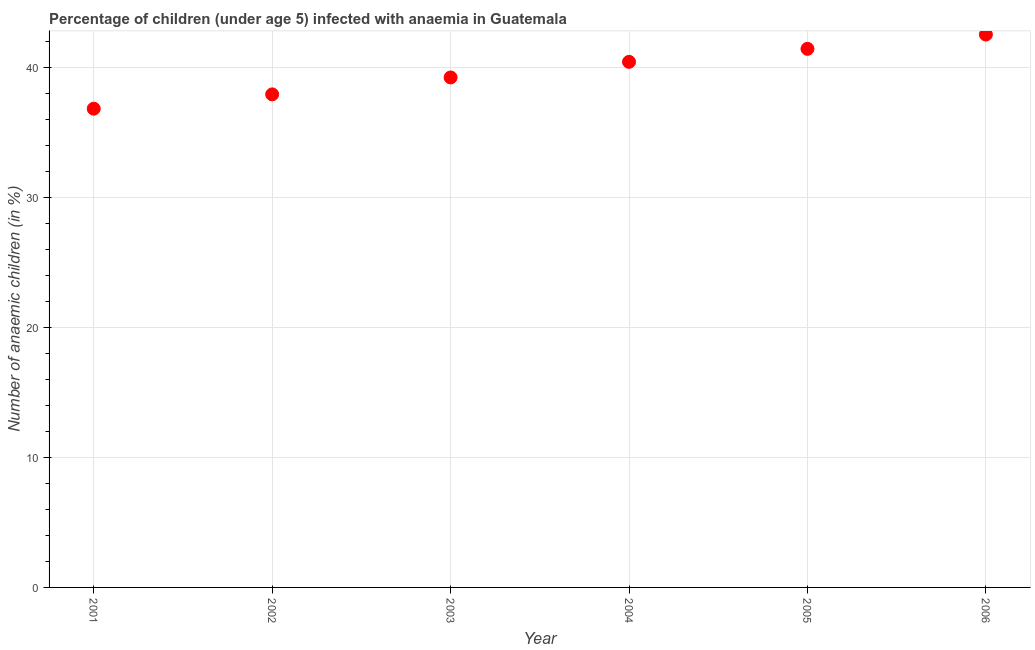What is the number of anaemic children in 2005?
Give a very brief answer. 41.4. Across all years, what is the maximum number of anaemic children?
Your answer should be very brief. 42.5. Across all years, what is the minimum number of anaemic children?
Provide a short and direct response. 36.8. In which year was the number of anaemic children minimum?
Provide a succinct answer. 2001. What is the sum of the number of anaemic children?
Offer a very short reply. 238.2. What is the difference between the number of anaemic children in 2002 and 2006?
Ensure brevity in your answer.  -4.6. What is the average number of anaemic children per year?
Make the answer very short. 39.7. What is the median number of anaemic children?
Your answer should be very brief. 39.8. Do a majority of the years between 2004 and 2002 (inclusive) have number of anaemic children greater than 38 %?
Your answer should be very brief. No. What is the ratio of the number of anaemic children in 2002 to that in 2004?
Give a very brief answer. 0.94. What is the difference between the highest and the second highest number of anaemic children?
Offer a very short reply. 1.1. What is the difference between the highest and the lowest number of anaemic children?
Keep it short and to the point. 5.7. Does the number of anaemic children monotonically increase over the years?
Make the answer very short. Yes. How many years are there in the graph?
Offer a terse response. 6. What is the difference between two consecutive major ticks on the Y-axis?
Ensure brevity in your answer.  10. Does the graph contain any zero values?
Offer a very short reply. No. Does the graph contain grids?
Offer a very short reply. Yes. What is the title of the graph?
Offer a very short reply. Percentage of children (under age 5) infected with anaemia in Guatemala. What is the label or title of the Y-axis?
Keep it short and to the point. Number of anaemic children (in %). What is the Number of anaemic children (in %) in 2001?
Give a very brief answer. 36.8. What is the Number of anaemic children (in %) in 2002?
Make the answer very short. 37.9. What is the Number of anaemic children (in %) in 2003?
Provide a succinct answer. 39.2. What is the Number of anaemic children (in %) in 2004?
Provide a succinct answer. 40.4. What is the Number of anaemic children (in %) in 2005?
Your answer should be very brief. 41.4. What is the Number of anaemic children (in %) in 2006?
Offer a very short reply. 42.5. What is the difference between the Number of anaemic children (in %) in 2002 and 2006?
Keep it short and to the point. -4.6. What is the difference between the Number of anaemic children (in %) in 2003 and 2006?
Provide a short and direct response. -3.3. What is the difference between the Number of anaemic children (in %) in 2004 and 2005?
Offer a terse response. -1. What is the difference between the Number of anaemic children (in %) in 2004 and 2006?
Provide a succinct answer. -2.1. What is the ratio of the Number of anaemic children (in %) in 2001 to that in 2003?
Ensure brevity in your answer.  0.94. What is the ratio of the Number of anaemic children (in %) in 2001 to that in 2004?
Provide a short and direct response. 0.91. What is the ratio of the Number of anaemic children (in %) in 2001 to that in 2005?
Give a very brief answer. 0.89. What is the ratio of the Number of anaemic children (in %) in 2001 to that in 2006?
Provide a succinct answer. 0.87. What is the ratio of the Number of anaemic children (in %) in 2002 to that in 2004?
Offer a terse response. 0.94. What is the ratio of the Number of anaemic children (in %) in 2002 to that in 2005?
Make the answer very short. 0.92. What is the ratio of the Number of anaemic children (in %) in 2002 to that in 2006?
Offer a terse response. 0.89. What is the ratio of the Number of anaemic children (in %) in 2003 to that in 2004?
Provide a short and direct response. 0.97. What is the ratio of the Number of anaemic children (in %) in 2003 to that in 2005?
Ensure brevity in your answer.  0.95. What is the ratio of the Number of anaemic children (in %) in 2003 to that in 2006?
Ensure brevity in your answer.  0.92. What is the ratio of the Number of anaemic children (in %) in 2004 to that in 2006?
Make the answer very short. 0.95. 